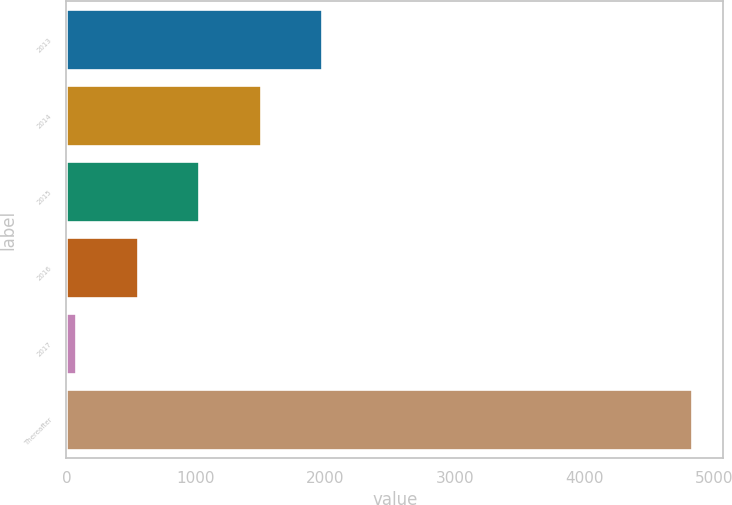<chart> <loc_0><loc_0><loc_500><loc_500><bar_chart><fcel>2013<fcel>2014<fcel>2015<fcel>2016<fcel>2017<fcel>Thereafter<nl><fcel>1977.68<fcel>1502.36<fcel>1027.04<fcel>551.72<fcel>76.4<fcel>4829.6<nl></chart> 